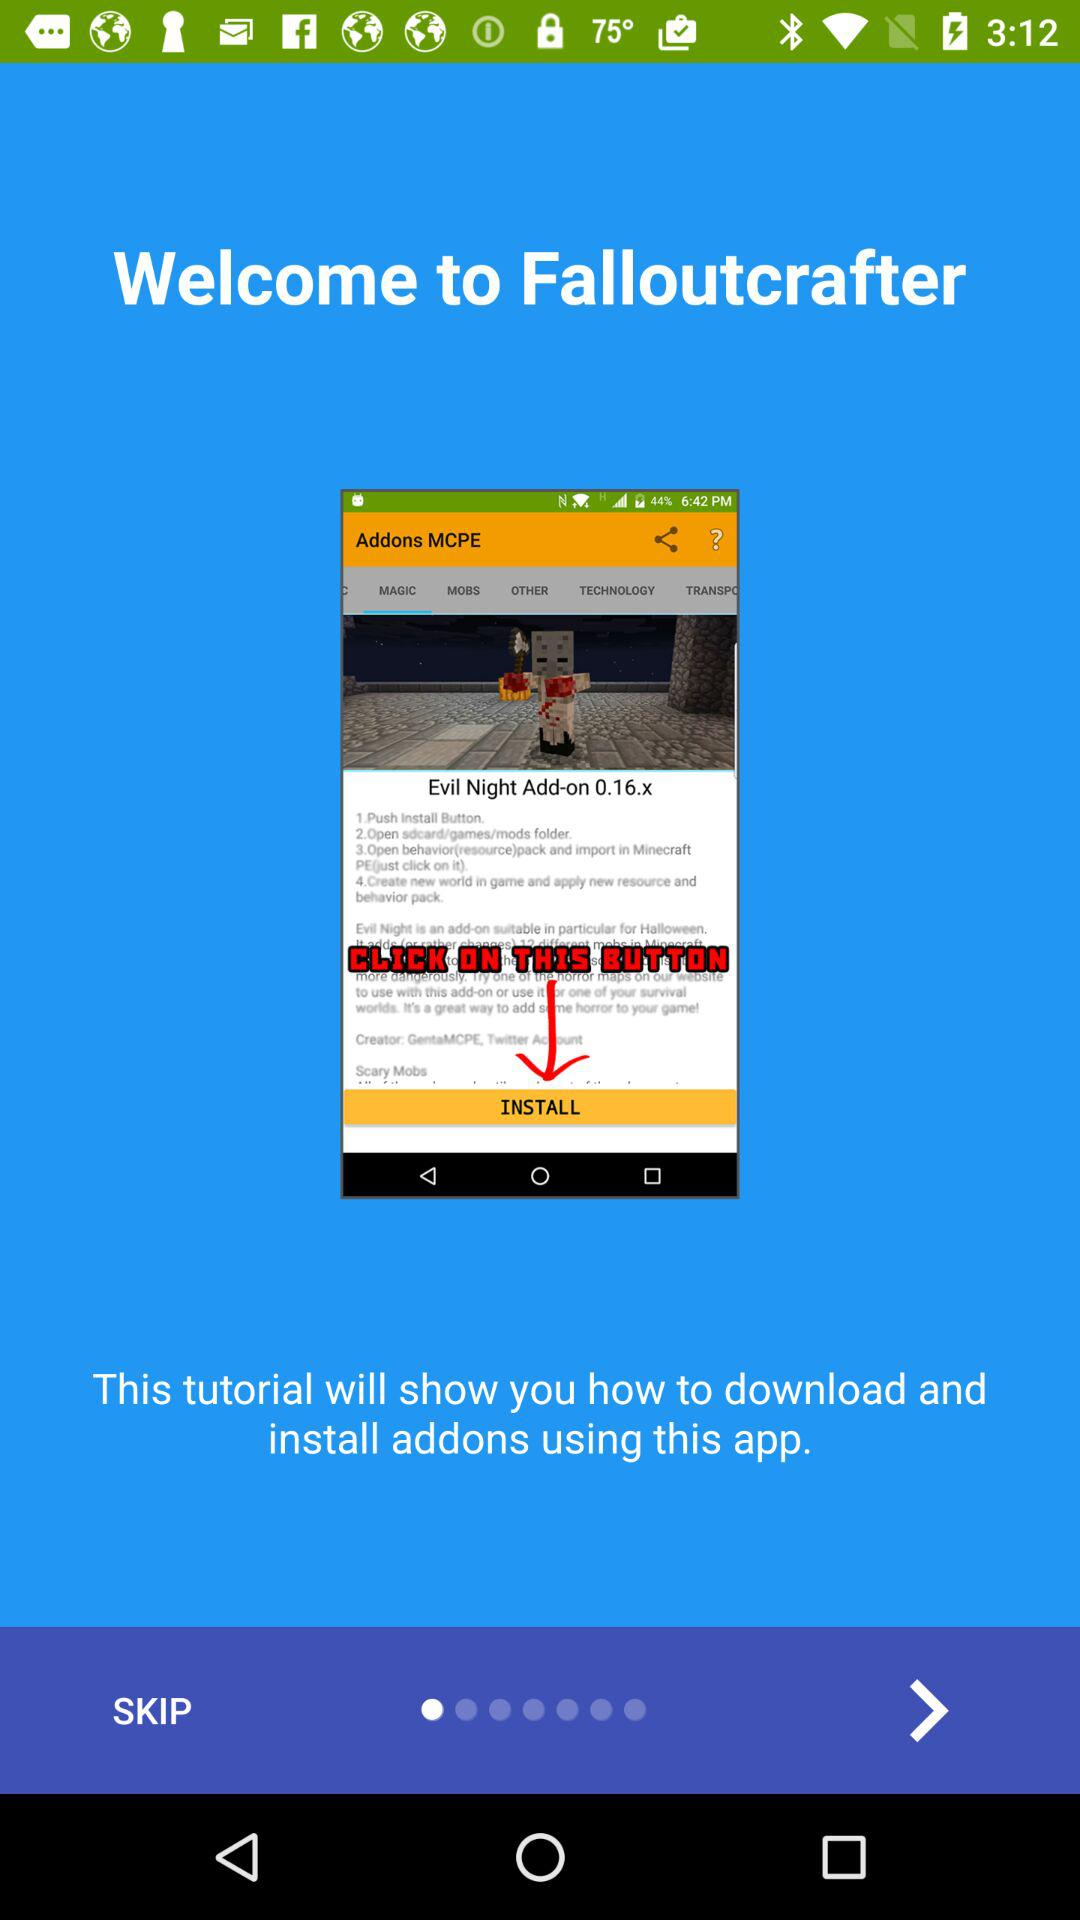What is the application name? The application name is "Falloutcrafter". 